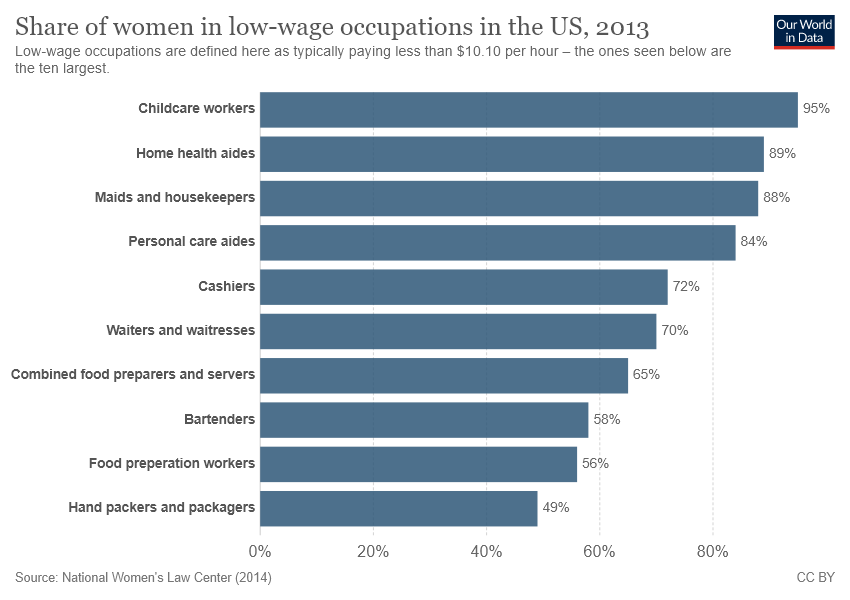Identify some key points in this picture. The share of women who work as cashiers is 0.72. The average share of women in the two lowest wage occupations is more than 90, indicating a significant gender disparity in the labor market. 